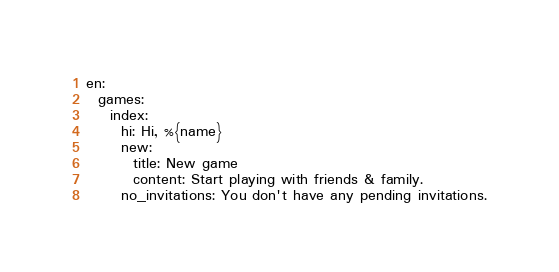<code> <loc_0><loc_0><loc_500><loc_500><_YAML_>en:
  games:
    index:
      hi: Hi, %{name}
      new:
        title: New game
        content: Start playing with friends & family.
      no_invitations: You don't have any pending invitations.
</code> 